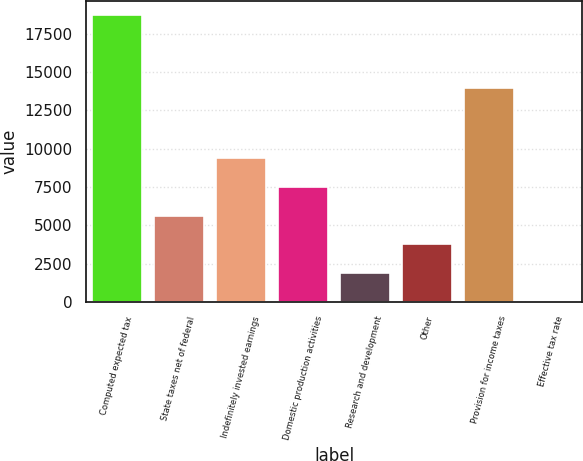Convert chart to OTSL. <chart><loc_0><loc_0><loc_500><loc_500><bar_chart><fcel>Computed expected tax<fcel>State taxes net of federal<fcel>Indefinitely invested earnings<fcel>Domestic production activities<fcel>Research and development<fcel>Other<fcel>Provision for income taxes<fcel>Effective tax rate<nl><fcel>18719<fcel>5633.97<fcel>9372.55<fcel>7503.26<fcel>1895.39<fcel>3764.68<fcel>13973<fcel>26.1<nl></chart> 